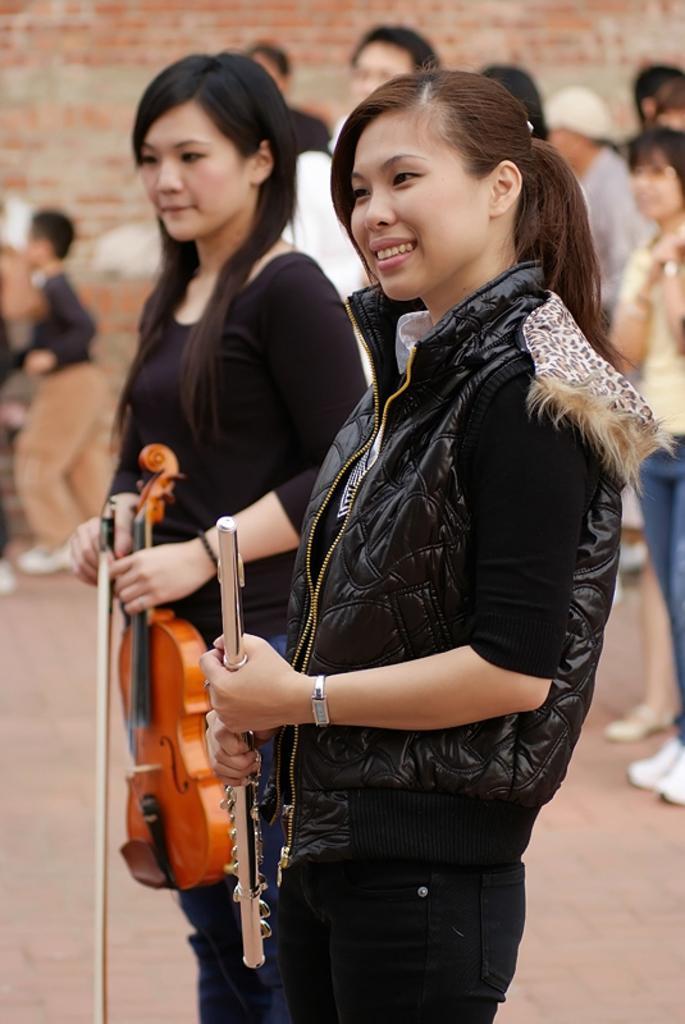Could you give a brief overview of what you see in this image? In this there are group of people. At the front there are two women standing and they are holding musical instruments. At the back there's a wall. 